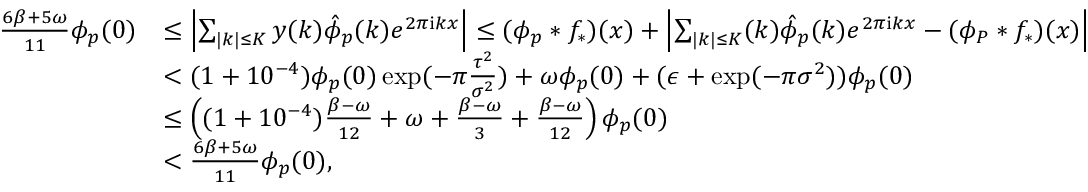<formula> <loc_0><loc_0><loc_500><loc_500>\begin{array} { r l } { \frac { 6 \beta + 5 \omega } { 1 1 } \phi _ { p } ( 0 ) } & { \leq \left | \sum _ { | k | \leq K } y ( k ) \hat { \phi } _ { p } ( k ) e ^ { 2 \pi i k x } \right | \leq ( \phi _ { p } * f _ { * } ) ( x ) + \left | \sum _ { | k | \leq K } ( k ) \hat { \phi } _ { p } ( k ) e ^ { 2 \pi i k x } - ( \phi _ { P } * f _ { * } ) ( x ) \right | } \\ & { < ( 1 + 1 0 ^ { - 4 } ) \phi _ { p } ( 0 ) \exp ( - \pi \frac { \tau ^ { 2 } } { \sigma ^ { 2 } } ) + \omega \phi _ { p } ( 0 ) + ( \epsilon + \exp ( - \pi \sigma ^ { 2 } ) ) \phi _ { p } ( 0 ) } \\ & { \leq \left ( ( 1 + 1 0 ^ { - 4 } ) \frac { \beta - \omega } { 1 2 } + \omega + \frac { \beta - \omega } { 3 } + \frac { \beta - \omega } { 1 2 } \right ) \phi _ { p } ( 0 ) } \\ & { < \frac { 6 \beta + 5 \omega } { 1 1 } \phi _ { p } ( 0 ) , } \end{array}</formula> 